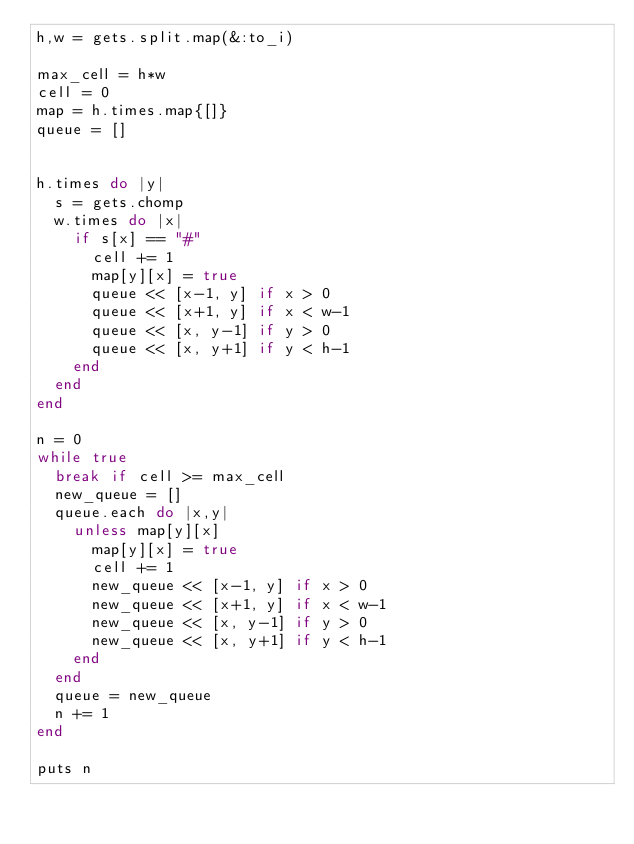<code> <loc_0><loc_0><loc_500><loc_500><_Ruby_>h,w = gets.split.map(&:to_i)

max_cell = h*w
cell = 0
map = h.times.map{[]}
queue = []


h.times do |y|
  s = gets.chomp
  w.times do |x|
    if s[x] == "#"
      cell += 1
      map[y][x] = true
      queue << [x-1, y] if x > 0
      queue << [x+1, y] if x < w-1
      queue << [x, y-1] if y > 0
      queue << [x, y+1] if y < h-1
    end
  end
end

n = 0
while true
  break if cell >= max_cell
  new_queue = []
  queue.each do |x,y|
    unless map[y][x]
      map[y][x] = true
      cell += 1
      new_queue << [x-1, y] if x > 0
      new_queue << [x+1, y] if x < w-1
      new_queue << [x, y-1] if y > 0
      new_queue << [x, y+1] if y < h-1
    end
  end
  queue = new_queue
  n += 1
end

puts n
</code> 